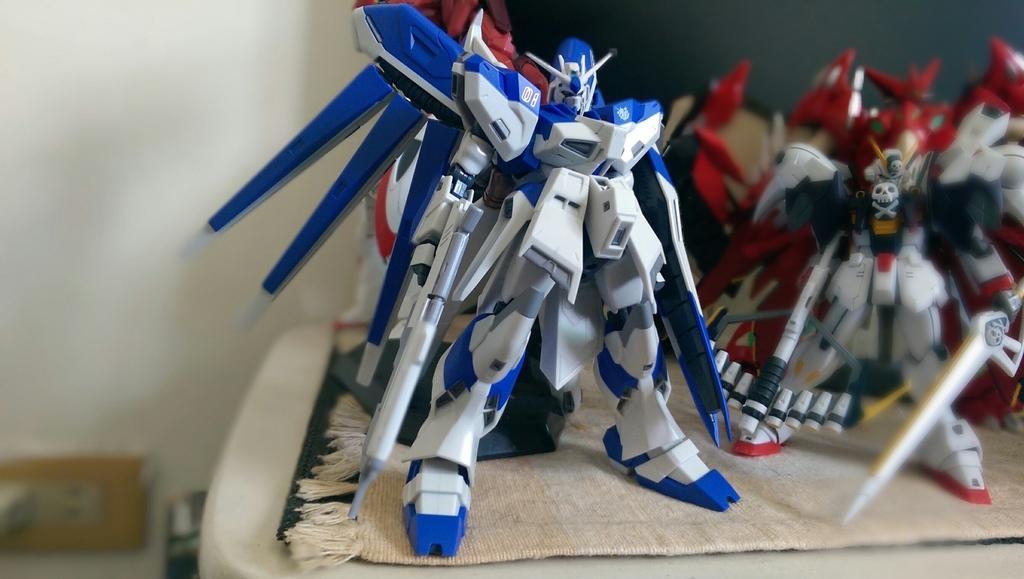Please provide a concise description of this image. In this image we can see some toys on the cloth, in the background we can see a socket on the wall. 